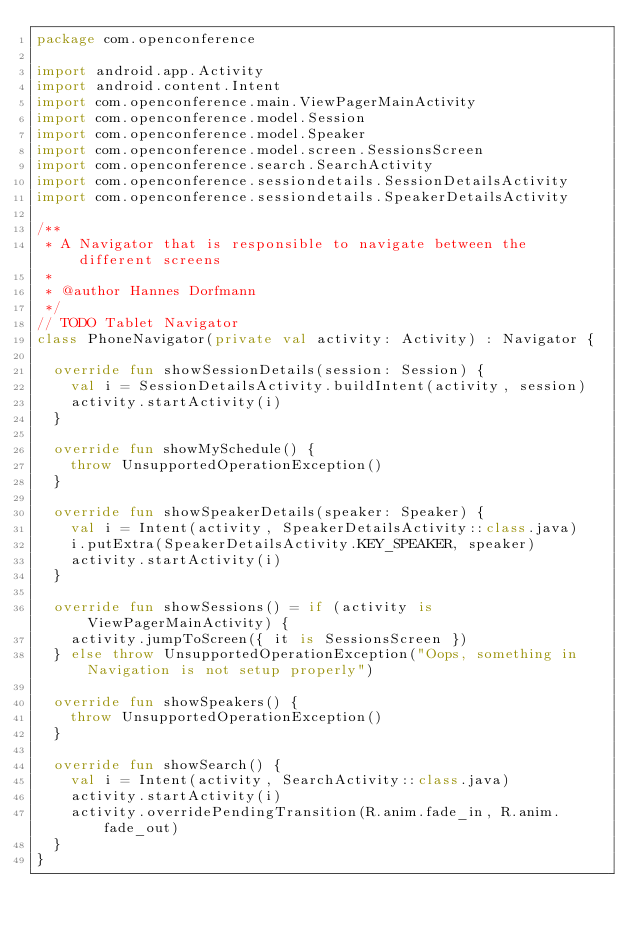Convert code to text. <code><loc_0><loc_0><loc_500><loc_500><_Kotlin_>package com.openconference

import android.app.Activity
import android.content.Intent
import com.openconference.main.ViewPagerMainActivity
import com.openconference.model.Session
import com.openconference.model.Speaker
import com.openconference.model.screen.SessionsScreen
import com.openconference.search.SearchActivity
import com.openconference.sessiondetails.SessionDetailsActivity
import com.openconference.sessiondetails.SpeakerDetailsActivity

/**
 * A Navigator that is responsible to navigate between the different screens
 *
 * @author Hannes Dorfmann
 */
// TODO Tablet Navigator
class PhoneNavigator(private val activity: Activity) : Navigator {

  override fun showSessionDetails(session: Session) {
    val i = SessionDetailsActivity.buildIntent(activity, session)
    activity.startActivity(i)
  }

  override fun showMySchedule() {
    throw UnsupportedOperationException()
  }

  override fun showSpeakerDetails(speaker: Speaker) {
    val i = Intent(activity, SpeakerDetailsActivity::class.java)
    i.putExtra(SpeakerDetailsActivity.KEY_SPEAKER, speaker)
    activity.startActivity(i)
  }

  override fun showSessions() = if (activity is ViewPagerMainActivity) {
    activity.jumpToScreen({ it is SessionsScreen })
  } else throw UnsupportedOperationException("Oops, something in Navigation is not setup properly")

  override fun showSpeakers() {
    throw UnsupportedOperationException()
  }

  override fun showSearch() {
    val i = Intent(activity, SearchActivity::class.java)
    activity.startActivity(i)
    activity.overridePendingTransition(R.anim.fade_in, R.anim.fade_out)
  }
}</code> 